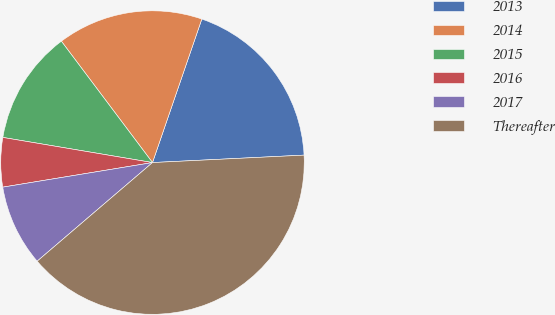Convert chart. <chart><loc_0><loc_0><loc_500><loc_500><pie_chart><fcel>2013<fcel>2014<fcel>2015<fcel>2016<fcel>2017<fcel>Thereafter<nl><fcel>18.95%<fcel>15.52%<fcel>12.1%<fcel>5.24%<fcel>8.67%<fcel>39.52%<nl></chart> 